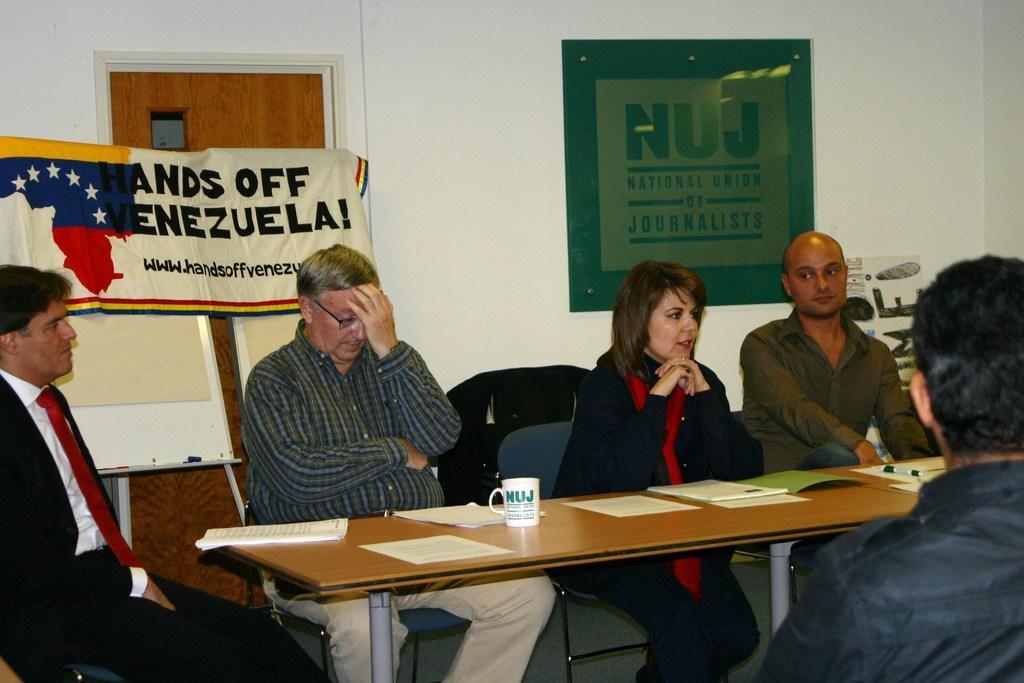Can you describe this image briefly? In this picture we can see five people four men and a women three men are sitting on chairs in front of a table and one women also sitting in front of a table in the background we can see a banner and a wall and I can see some of the chairs here, the man on the left side is wearing a suit. 